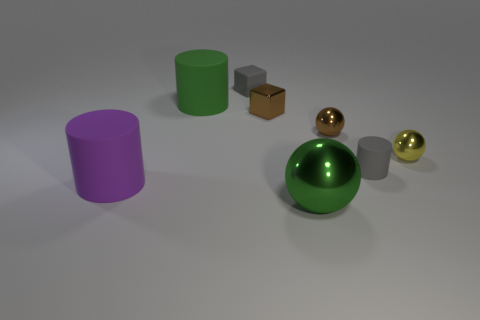Subtract all big green balls. How many balls are left? 2 Add 1 yellow balls. How many objects exist? 9 Subtract all gray cubes. How many cubes are left? 1 Subtract 1 blocks. How many blocks are left? 1 Subtract all purple cubes. Subtract all blue balls. How many cubes are left? 2 Add 1 big cyan spheres. How many big cyan spheres exist? 1 Subtract 0 purple blocks. How many objects are left? 8 Subtract all blocks. How many objects are left? 6 Subtract all yellow cylinders. How many blue blocks are left? 0 Subtract all green cylinders. Subtract all purple rubber cylinders. How many objects are left? 6 